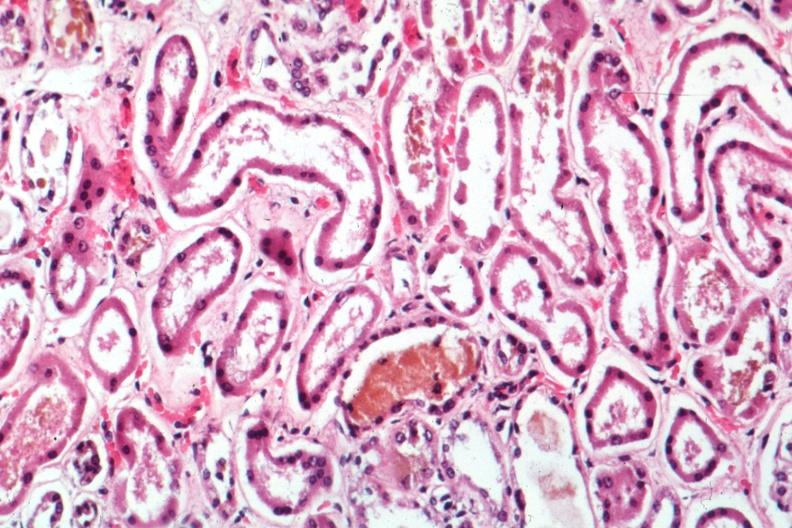what is present?
Answer the question using a single word or phrase. Acute tubular necrosis 